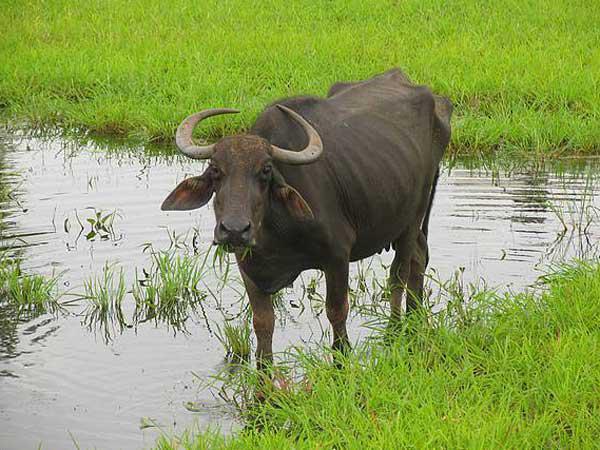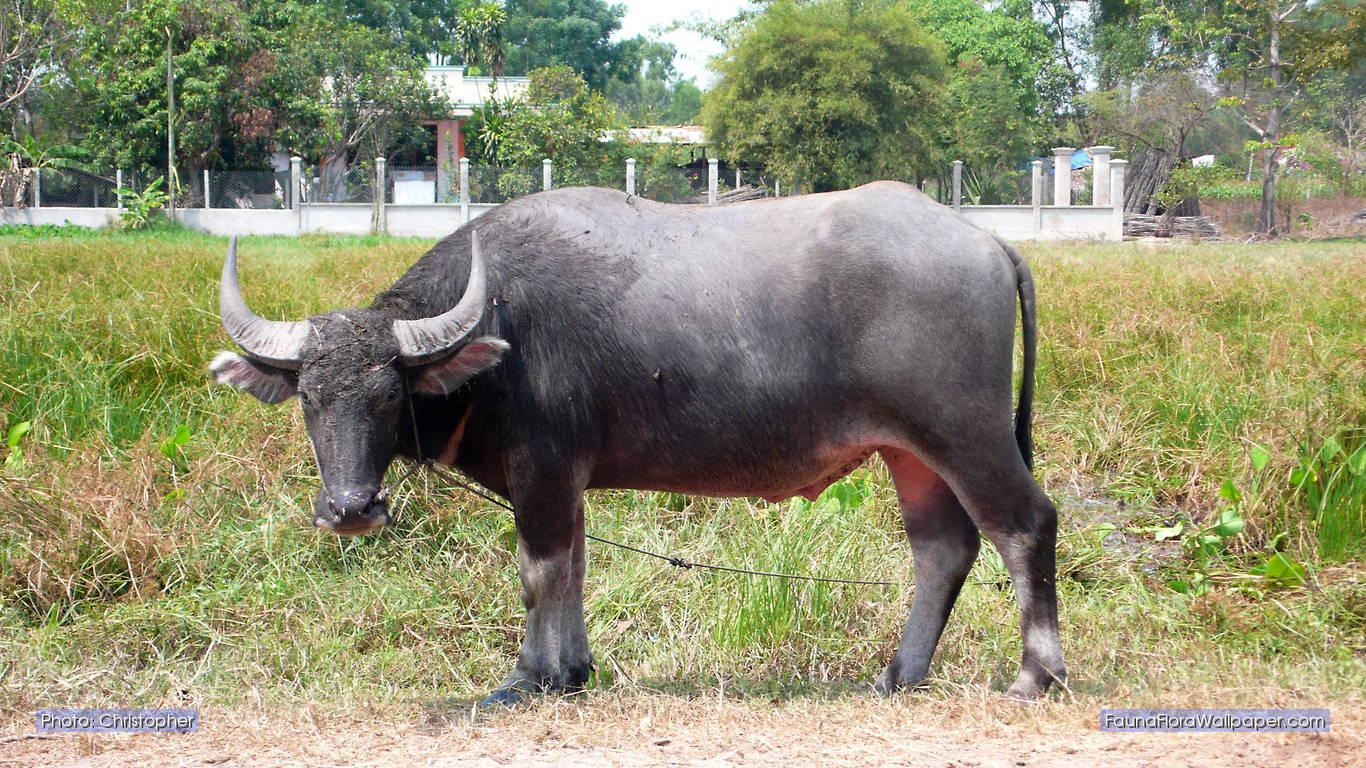The first image is the image on the left, the second image is the image on the right. For the images displayed, is the sentence "The animal in the image on the right is standing in side profile with its head turned toward the camera." factually correct? Answer yes or no. Yes. 